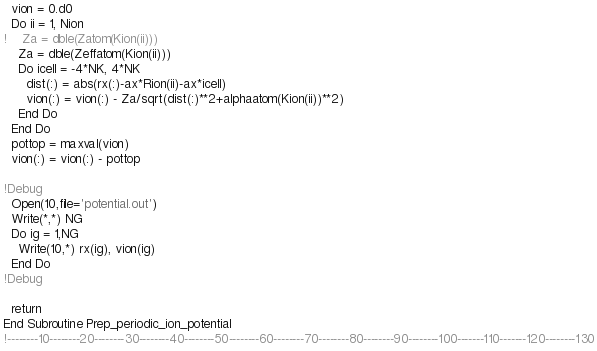<code> <loc_0><loc_0><loc_500><loc_500><_FORTRAN_>
  vion = 0.d0
  Do ii = 1, Nion
!    Za = dble(Zatom(Kion(ii)))
    Za = dble(Zeffatom(Kion(ii)))
    Do icell = -4*NK, 4*NK
      dist(:) = abs(rx(:)-ax*Rion(ii)-ax*icell)
      vion(:) = vion(:) - Za/sqrt(dist(:)**2+alphaatom(Kion(ii))**2)
    End Do
  End Do
  pottop = maxval(vion)
  vion(:) = vion(:) - pottop
  
!Debug
  Open(10,file='potential.out')
  Write(*,*) NG
  Do ig = 1,NG
    Write(10,*) rx(ig), vion(ig)
  End Do
!Debug

  return
End Subroutine Prep_periodic_ion_potential
!--------10--------20--------30--------40--------50--------60--------70--------80--------90--------100-------110-------120--------130
</code> 